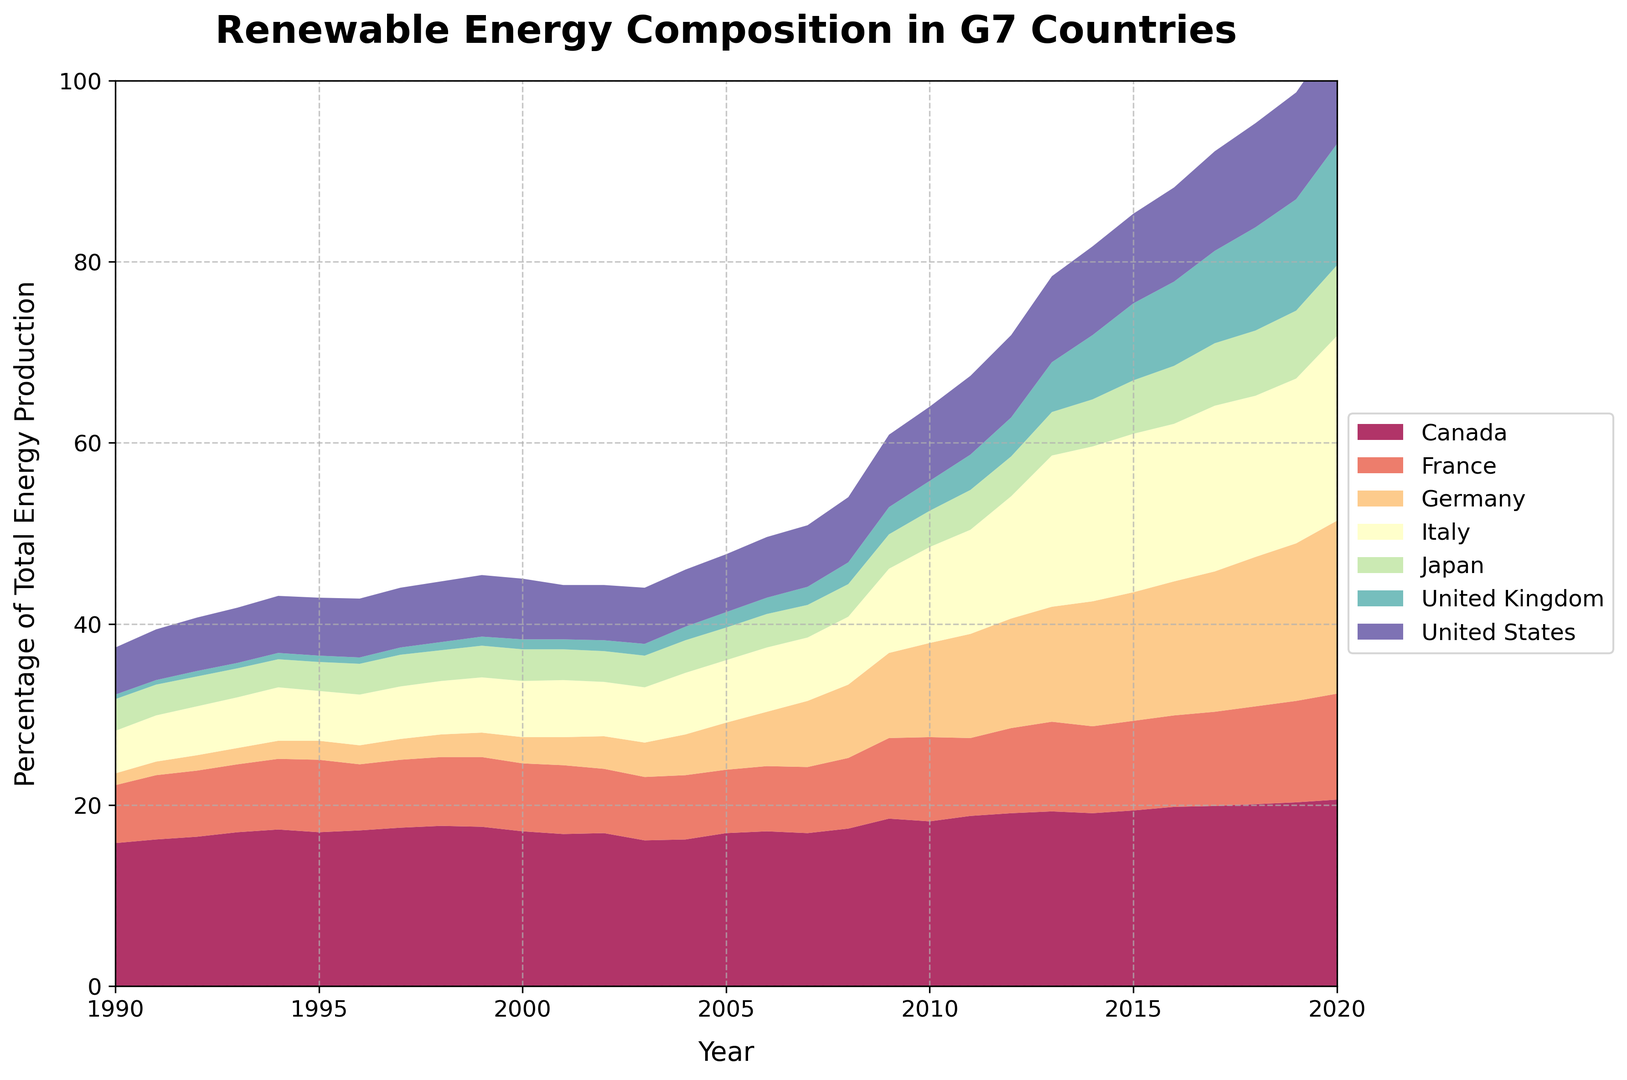Which country had the highest percentage of renewable energy in total energy production in 2020? To answer this, look at the end of the data lines in the area chart for 2020 and identify the highest value. The label on the color legend can help identify the country.
Answer: Canada Which country showed the most significant increase in renewable energy percentage from 1990 to 2020? To determine this, examine the slopes of the areas from 1990 to 2020. The country with the greatest vertical difference between these years represents the largest increase.
Answer: Germany In what year did Italy's renewable energy percentage surpass France's? Compare the areas for Italy and France visually and find the point where Italy's area exceeds France's area for the first time.
Answer: 2008 How does the renewable energy percentage of the United Kingdom in 2000 compare to that in 2020? Refer to the United Kingdom's area in both 2000 and 2020 to see how its height changes over time.
Answer: It increased from a small area in 2000 to a significantly larger area in 2020 What was the approximate median percentage of renewable energy for Germany between 1990 and 2020? Identify all the values for Germany from 1990 to 2020, then locate the median value by arranging these values in ascending order and finding the middle number.
Answer: Around 7.3% By how many percentage points did the United States' renewable energy production increase from 1990 to 2020? Subtract the 1990 value for the United States from the 2020 value.
Answer: 7 percentage points Which countries had a renewable energy percentage below 5% in 1990? Look at the starting points (1990) for each country's area and identify those below the 5% level on the vertical axis.
Answer: Germany, Italy, Japan, United Kingdom 